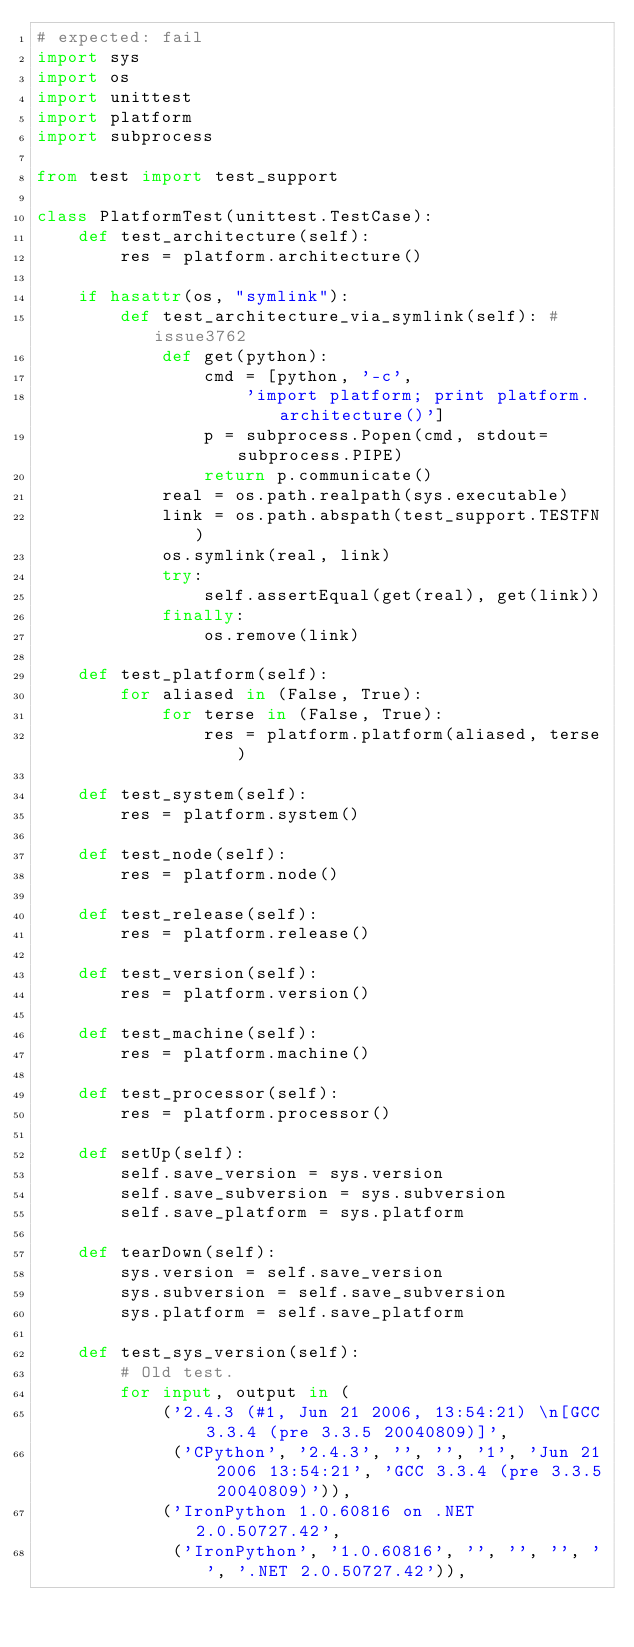Convert code to text. <code><loc_0><loc_0><loc_500><loc_500><_Python_># expected: fail
import sys
import os
import unittest
import platform
import subprocess

from test import test_support

class PlatformTest(unittest.TestCase):
    def test_architecture(self):
        res = platform.architecture()

    if hasattr(os, "symlink"):
        def test_architecture_via_symlink(self): # issue3762
            def get(python):
                cmd = [python, '-c',
                    'import platform; print platform.architecture()']
                p = subprocess.Popen(cmd, stdout=subprocess.PIPE)
                return p.communicate()
            real = os.path.realpath(sys.executable)
            link = os.path.abspath(test_support.TESTFN)
            os.symlink(real, link)
            try:
                self.assertEqual(get(real), get(link))
            finally:
                os.remove(link)

    def test_platform(self):
        for aliased in (False, True):
            for terse in (False, True):
                res = platform.platform(aliased, terse)

    def test_system(self):
        res = platform.system()

    def test_node(self):
        res = platform.node()

    def test_release(self):
        res = platform.release()

    def test_version(self):
        res = platform.version()

    def test_machine(self):
        res = platform.machine()

    def test_processor(self):
        res = platform.processor()

    def setUp(self):
        self.save_version = sys.version
        self.save_subversion = sys.subversion
        self.save_platform = sys.platform

    def tearDown(self):
        sys.version = self.save_version
        sys.subversion = self.save_subversion
        sys.platform = self.save_platform

    def test_sys_version(self):
        # Old test.
        for input, output in (
            ('2.4.3 (#1, Jun 21 2006, 13:54:21) \n[GCC 3.3.4 (pre 3.3.5 20040809)]',
             ('CPython', '2.4.3', '', '', '1', 'Jun 21 2006 13:54:21', 'GCC 3.3.4 (pre 3.3.5 20040809)')),
            ('IronPython 1.0.60816 on .NET 2.0.50727.42',
             ('IronPython', '1.0.60816', '', '', '', '', '.NET 2.0.50727.42')),</code> 